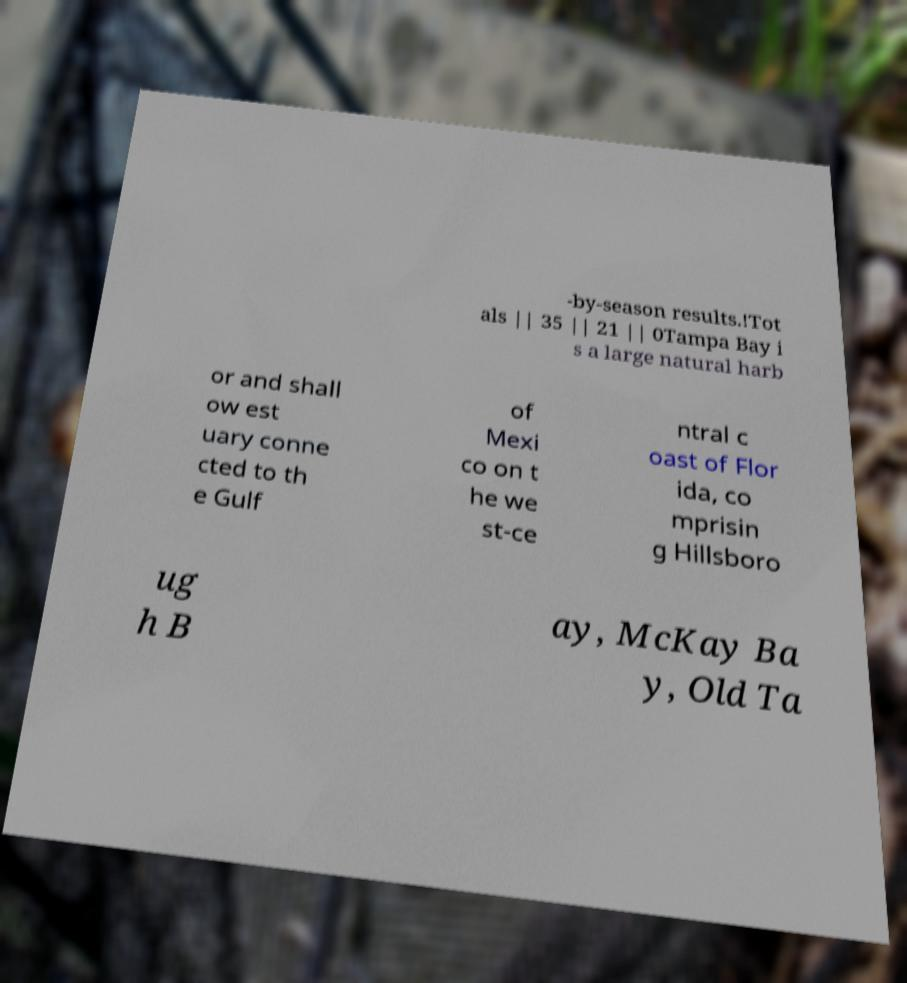I need the written content from this picture converted into text. Can you do that? -by-season results.!Tot als || 35 || 21 || 0Tampa Bay i s a large natural harb or and shall ow est uary conne cted to th e Gulf of Mexi co on t he we st-ce ntral c oast of Flor ida, co mprisin g Hillsboro ug h B ay, McKay Ba y, Old Ta 